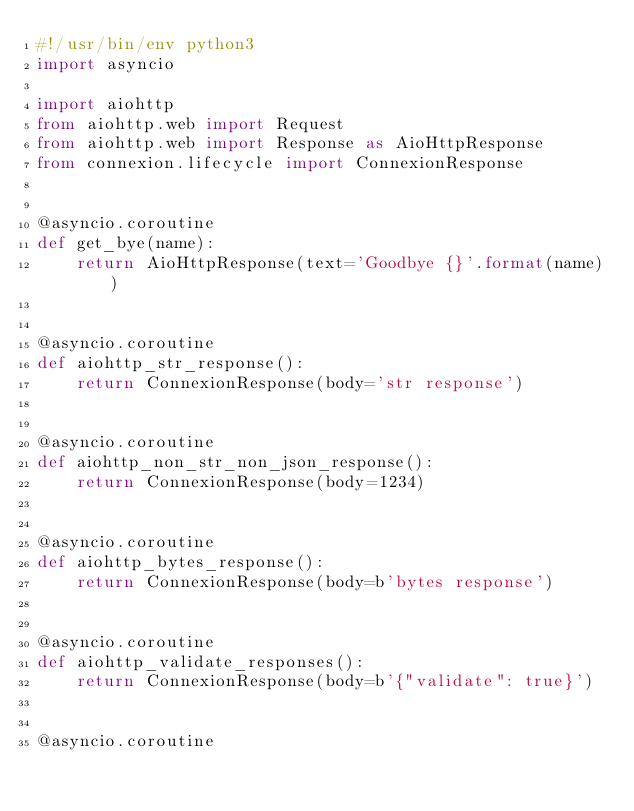<code> <loc_0><loc_0><loc_500><loc_500><_Python_>#!/usr/bin/env python3
import asyncio

import aiohttp
from aiohttp.web import Request
from aiohttp.web import Response as AioHttpResponse
from connexion.lifecycle import ConnexionResponse


@asyncio.coroutine
def get_bye(name):
    return AioHttpResponse(text='Goodbye {}'.format(name))


@asyncio.coroutine
def aiohttp_str_response():
    return ConnexionResponse(body='str response')


@asyncio.coroutine
def aiohttp_non_str_non_json_response():
    return ConnexionResponse(body=1234)


@asyncio.coroutine
def aiohttp_bytes_response():
    return ConnexionResponse(body=b'bytes response')


@asyncio.coroutine
def aiohttp_validate_responses():
    return ConnexionResponse(body=b'{"validate": true}')


@asyncio.coroutine</code> 